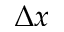<formula> <loc_0><loc_0><loc_500><loc_500>\Delta x</formula> 